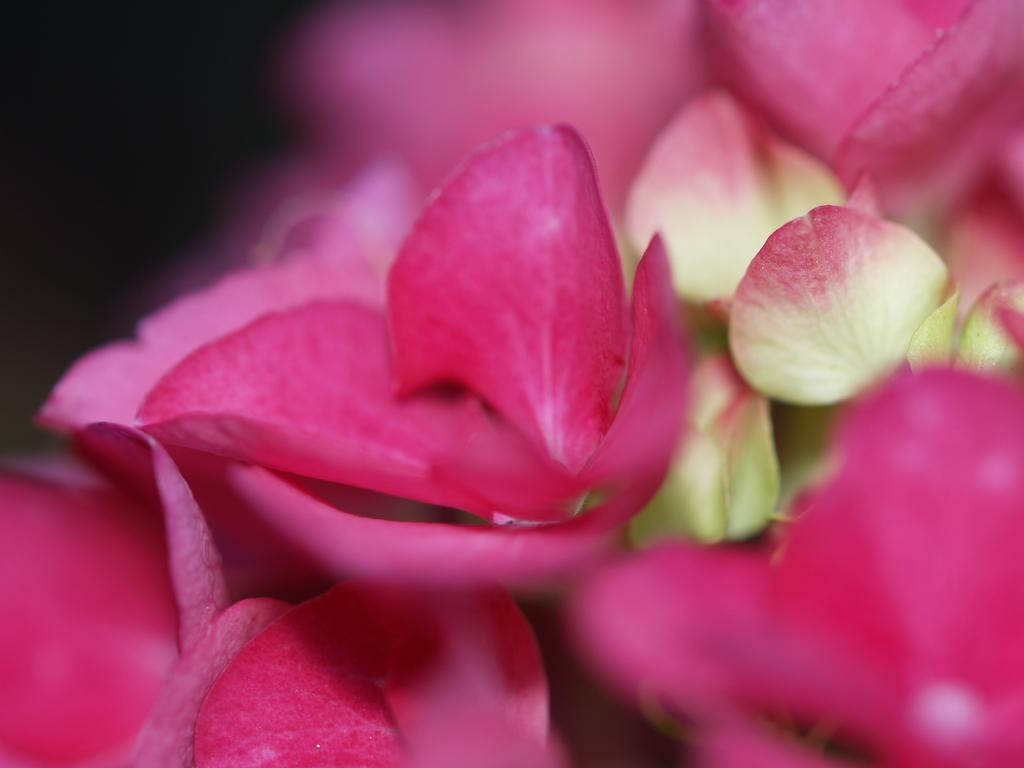What type of living organisms can be seen in the image? There are flowers in the image. What is the color of the background in the image? The background of the image is dark. How many lizards can be seen crawling on the flowers in the image? There are no lizards present in the image; it only features flowers. What type of industry is depicted in the image? There is no industry depicted in the image; it only features flowers and a dark background. 